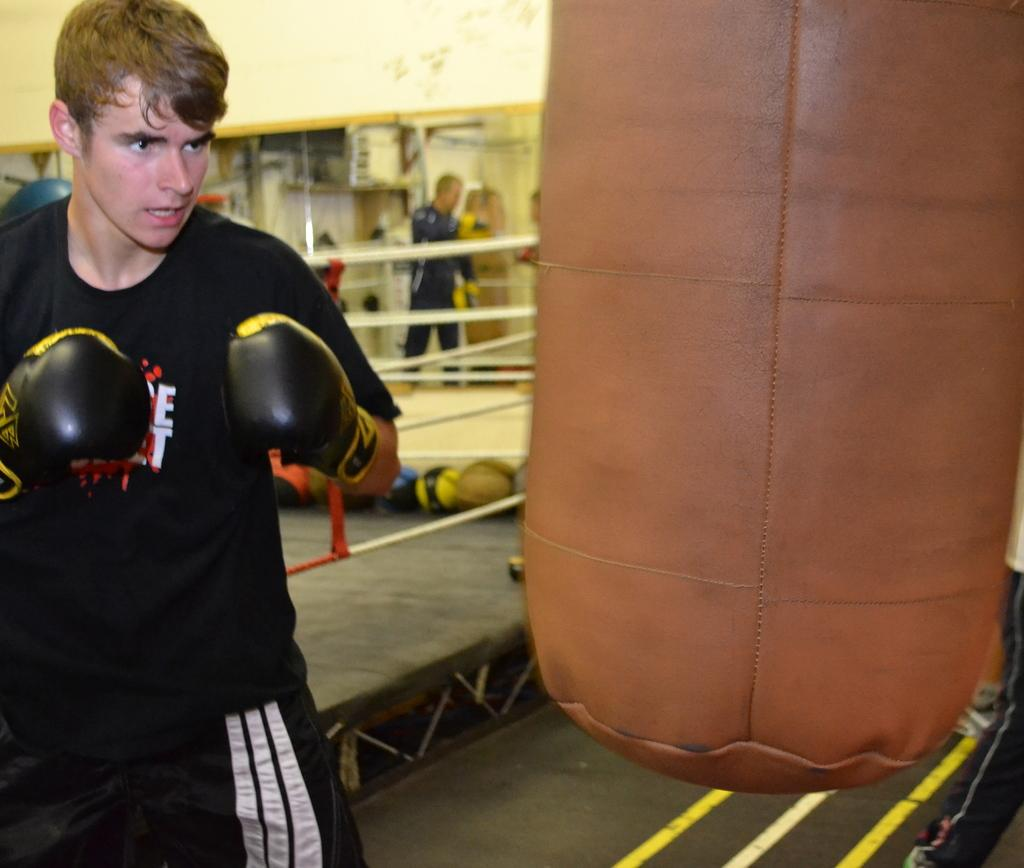What is the man in the image wearing on his hands? The man in the image is wearing boxing gloves. What object is the man likely to be using for training in the image? There is a punching bag in the image, which the man might be using for training. What type of sports equipment can be seen in the image? There are balls and ropes visible in the image. Can you describe the group of people in the image? There is a group of people standing in the image. What other items can be seen in the image? There are other items in the image, but their specific nature is not mentioned in the provided facts. Can you tell me how many snails are crawling on the ropes in the image? There is no mention of snails in the image, so it is not possible to answer this question. 